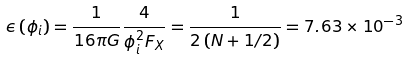<formula> <loc_0><loc_0><loc_500><loc_500>\epsilon \left ( \phi _ { i } \right ) = \frac { 1 } { 1 6 \pi G } \frac { 4 } { \phi _ { i } ^ { 2 } F _ { X } } = \frac { 1 } { 2 \left ( N + 1 / 2 \right ) } = 7 . 6 3 \times 1 0 ^ { - 3 }</formula> 